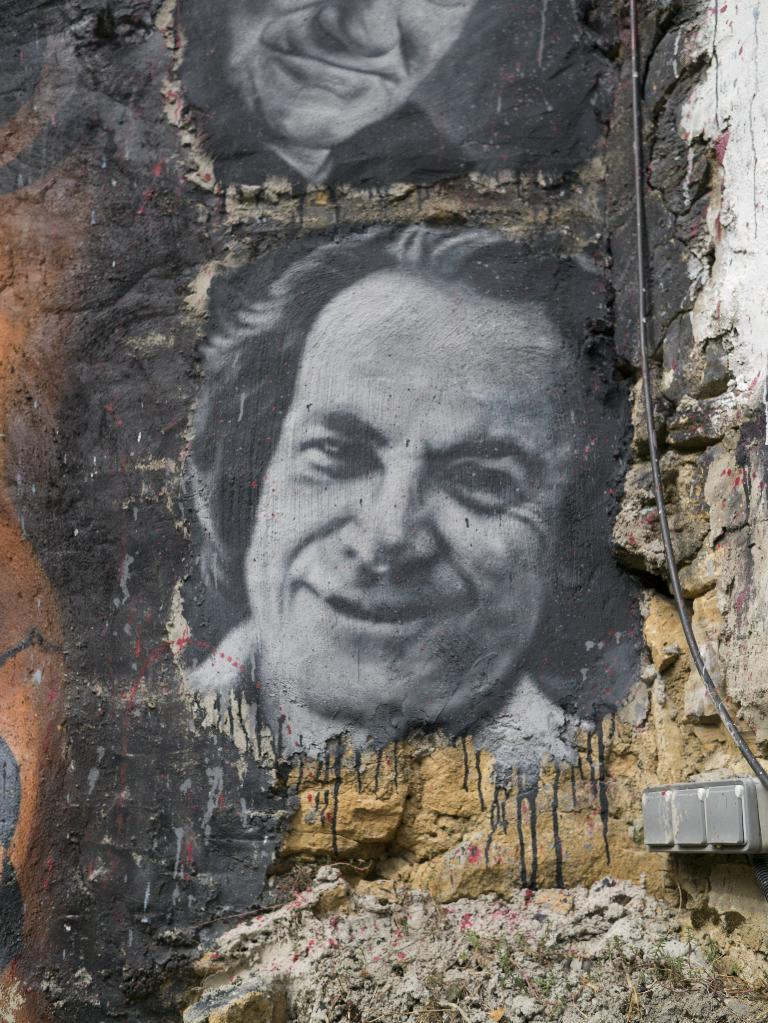What is featured in the image? There are paintings in the image. What do the paintings depict? The paintings depict persons. Where are the paintings located? The paintings are on a wall. What type of amusement can be seen in the bedroom in the image? There is no bedroom or amusement present in the image; it only features paintings depicting persons on a wall. 